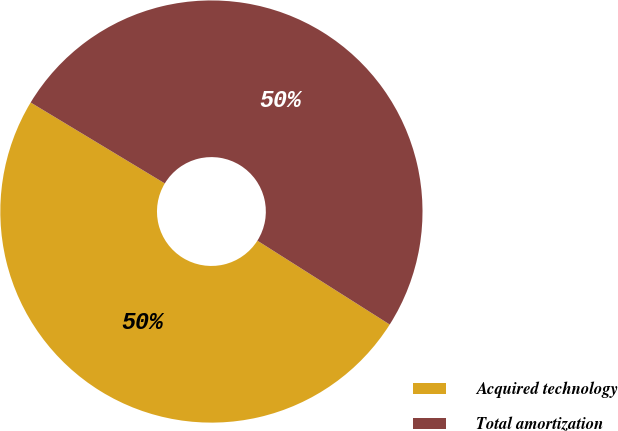Convert chart to OTSL. <chart><loc_0><loc_0><loc_500><loc_500><pie_chart><fcel>Acquired technology<fcel>Total amortization<nl><fcel>49.65%<fcel>50.35%<nl></chart> 